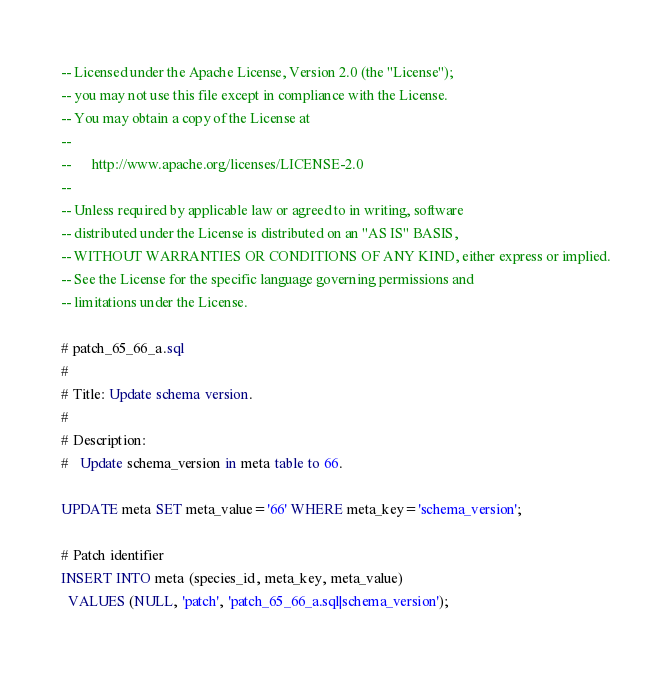<code> <loc_0><loc_0><loc_500><loc_500><_SQL_>-- Licensed under the Apache License, Version 2.0 (the "License");
-- you may not use this file except in compliance with the License.
-- You may obtain a copy of the License at
-- 
--      http://www.apache.org/licenses/LICENSE-2.0
-- 
-- Unless required by applicable law or agreed to in writing, software
-- distributed under the License is distributed on an "AS IS" BASIS,
-- WITHOUT WARRANTIES OR CONDITIONS OF ANY KIND, either express or implied.
-- See the License for the specific language governing permissions and
-- limitations under the License.

# patch_65_66_a.sql
#
# Title: Update schema version.
#
# Description:
#   Update schema_version in meta table to 66.

UPDATE meta SET meta_value='66' WHERE meta_key='schema_version';

# Patch identifier
INSERT INTO meta (species_id, meta_key, meta_value)
  VALUES (NULL, 'patch', 'patch_65_66_a.sql|schema_version');
</code> 